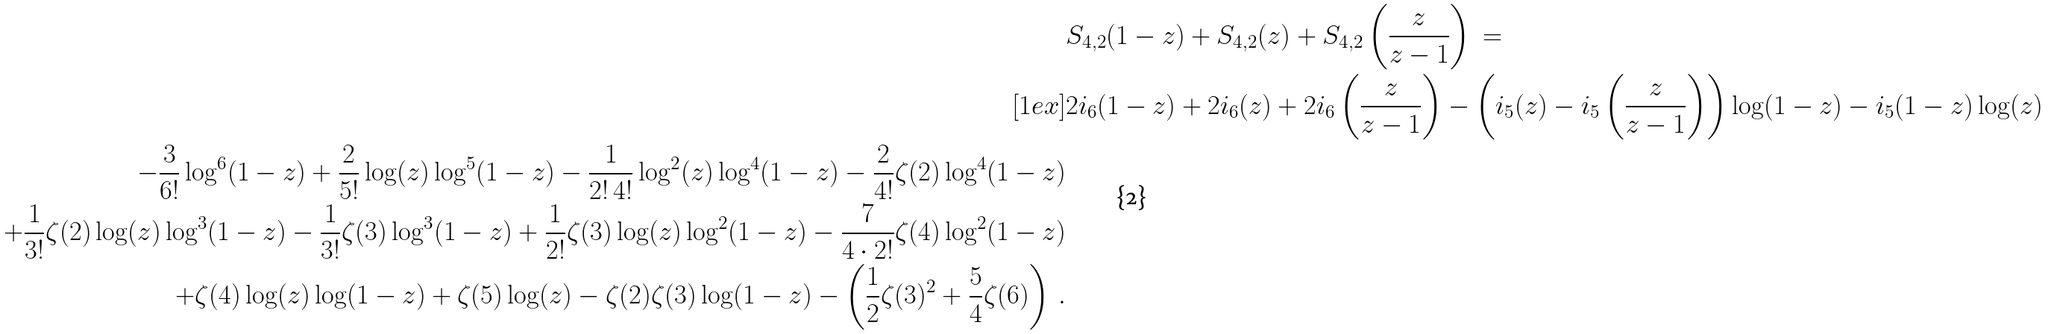Convert formula to latex. <formula><loc_0><loc_0><loc_500><loc_500>& S _ { 4 , 2 } ( 1 - z ) + S _ { 4 , 2 } ( z ) + S _ { 4 , 2 } \left ( \frac { z } { z - 1 } \right ) \ = \\ [ 1 e x ] & 2 \L i _ { 6 } ( 1 - z ) + 2 \L i _ { 6 } ( z ) + 2 \L i _ { 6 } \left ( \frac { z } { z - 1 } \right ) - \left ( \L i _ { 5 } ( z ) - \L i _ { 5 } \left ( \frac { z } { z - 1 } \right ) \right ) \log ( 1 - z ) - \L i _ { 5 } ( 1 - z ) \log ( z ) \\ - \frac { 3 } { 6 ! } \log ^ { 6 } ( 1 - z ) + \frac { 2 } { 5 ! } \log ( z ) \log ^ { 5 } ( 1 - z ) - \frac { 1 } { 2 ! \, 4 ! } \log ^ { 2 } ( z ) \log ^ { 4 } ( 1 - z ) - \frac { 2 } { 4 ! } \zeta ( 2 ) \log ^ { 4 } ( 1 - z ) \\ + \frac { 1 } { 3 ! } \zeta ( 2 ) \log ( z ) \log ^ { 3 } ( 1 - z ) - \frac { 1 } { 3 ! } \zeta ( 3 ) \log ^ { 3 } ( 1 - z ) + \frac { 1 } { 2 ! } \zeta ( 3 ) \log ( z ) \log ^ { 2 } ( 1 - z ) - \frac { 7 } { 4 \cdot 2 ! } \zeta ( 4 ) \log ^ { 2 } ( 1 - z ) \\ + \zeta ( 4 ) \log ( z ) \log ( 1 - z ) + \zeta ( 5 ) \log ( z ) - \zeta ( 2 ) \zeta ( 3 ) \log ( 1 - z ) - \left ( \frac { 1 } { 2 } \zeta ( 3 ) ^ { 2 } + \frac { 5 } { 4 } \zeta ( 6 ) \right ) \, .</formula> 